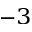Convert formula to latex. <formula><loc_0><loc_0><loc_500><loc_500>^ { - 3 }</formula> 